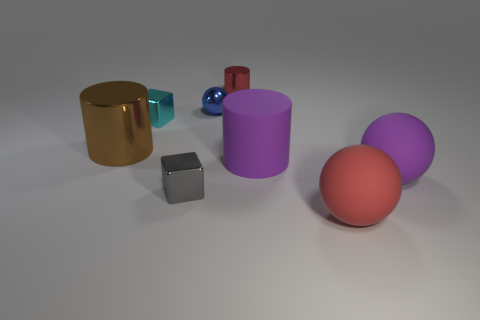Subtract all purple rubber cylinders. How many cylinders are left? 2 Add 2 big metallic objects. How many objects exist? 10 Subtract all brown cylinders. How many cylinders are left? 2 Subtract 1 cubes. How many cubes are left? 1 Add 3 large purple matte cylinders. How many large purple matte cylinders exist? 4 Subtract 0 blue blocks. How many objects are left? 8 Subtract all cylinders. How many objects are left? 5 Subtract all purple balls. Subtract all brown cylinders. How many balls are left? 2 Subtract all big purple rubber cylinders. Subtract all big purple rubber cylinders. How many objects are left? 6 Add 2 rubber cylinders. How many rubber cylinders are left? 3 